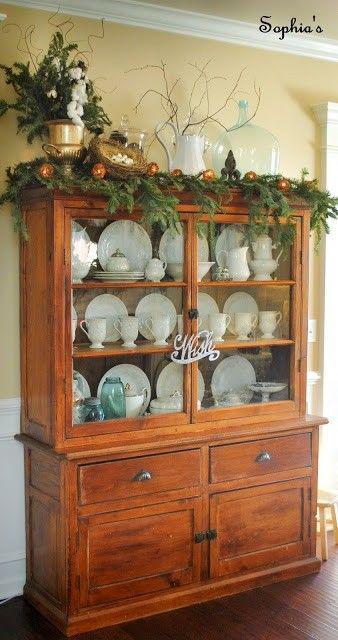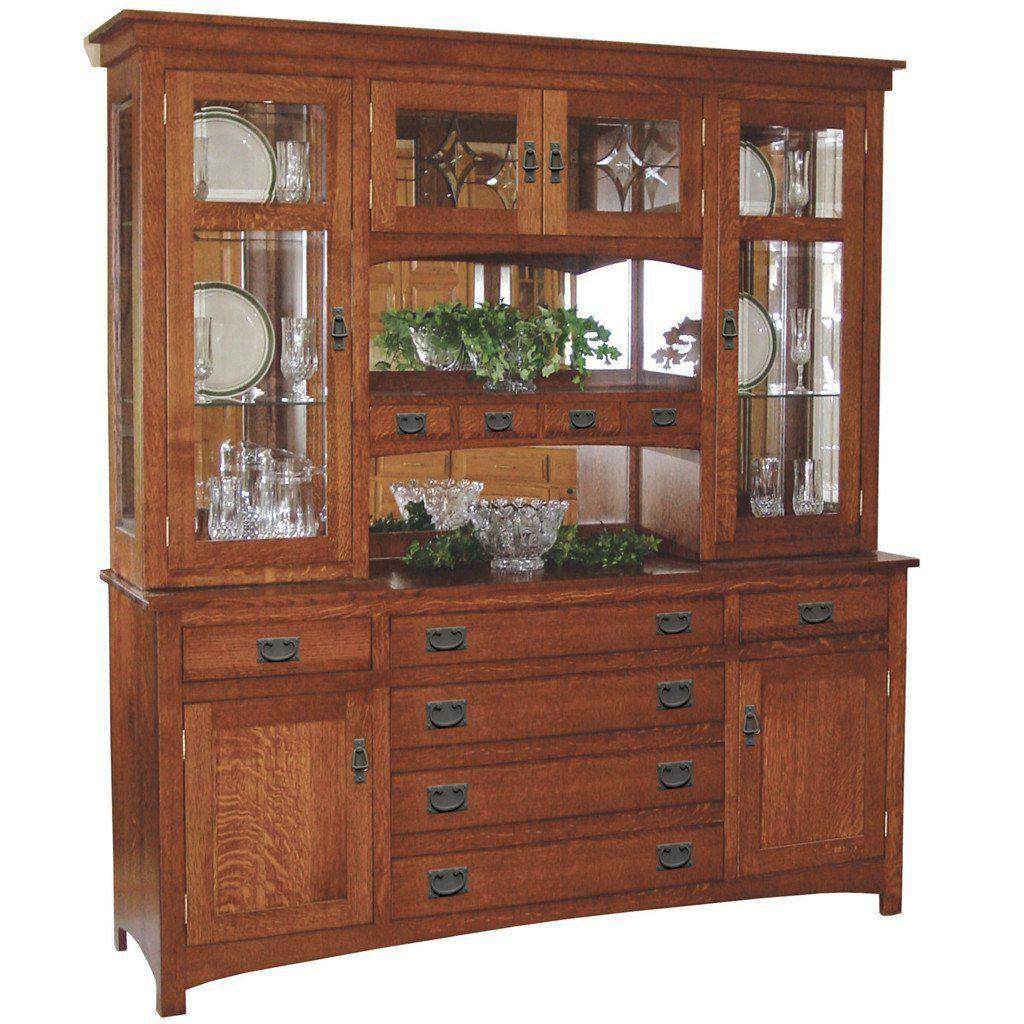The first image is the image on the left, the second image is the image on the right. Examine the images to the left and right. Is the description "All china cabinets have solid doors and drawers at the bottom and glass fronted doors on top." accurate? Answer yes or no. Yes. The first image is the image on the left, the second image is the image on the right. Analyze the images presented: Is the assertion "There is a plant resting on top of one of the furniture." valid? Answer yes or no. Yes. 